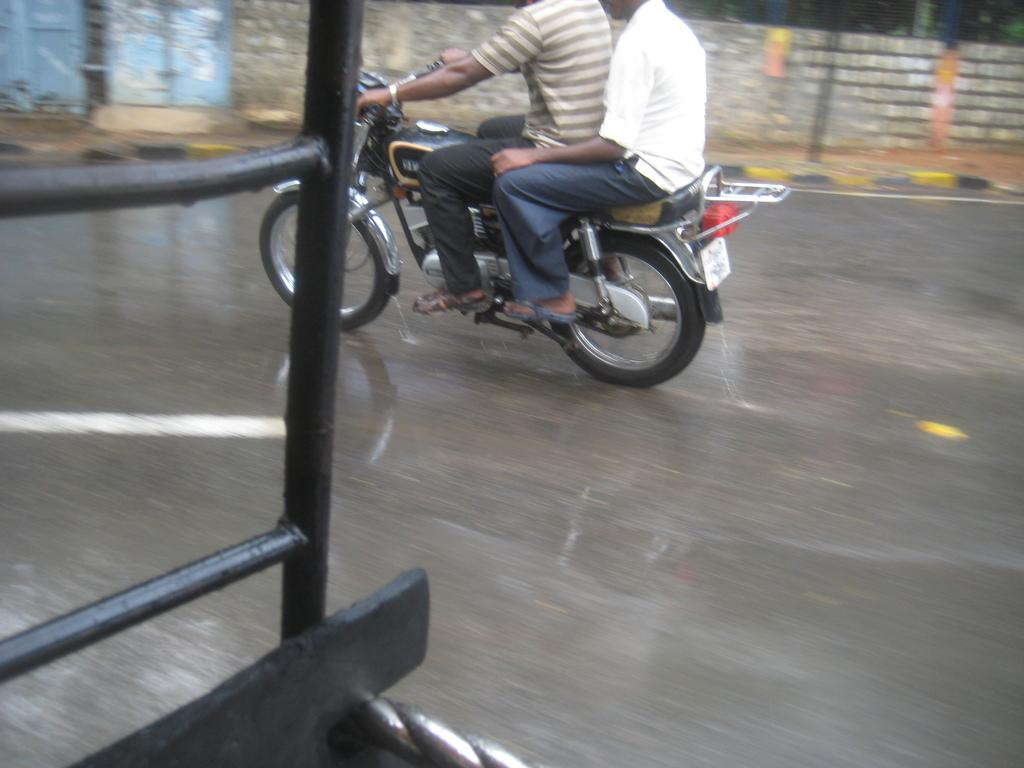How many people are in the image? There are two persons in the image. What are the two persons doing in the image? The two persons are on a motorcycle. Where is the motorcycle located in the image? The motorcycle is travelling on a road. What can be seen in the background of the image? There is a wall visible in the image. What type of noise can be heard coming from the cub in the image? There is no cub present in the image, so it is not possible to determine what noise might be heard. 